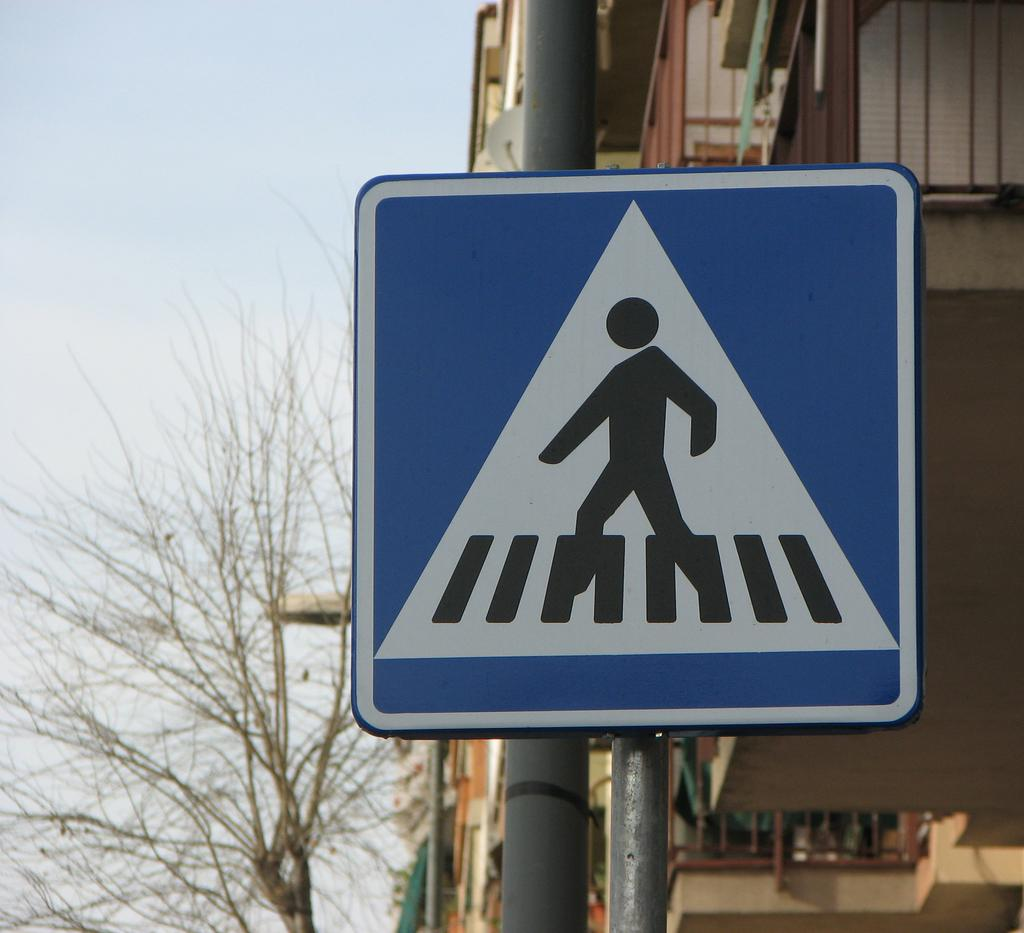What type of structures can be seen in the image? There are buildings in the image. What natural element is present in the image? There is a tree in the image. What type of man-made object can be seen providing illumination? There is a street light in the image. What type of informational display is present in the image? There is a sign board in the image. Can you see any planes flying over the harbor in the image? There is no harbor or planes visible in the image. What type of watch is being worn by the tree in the image? There is no watch present in the image, as the tree is a natural element and does not wear accessories. 